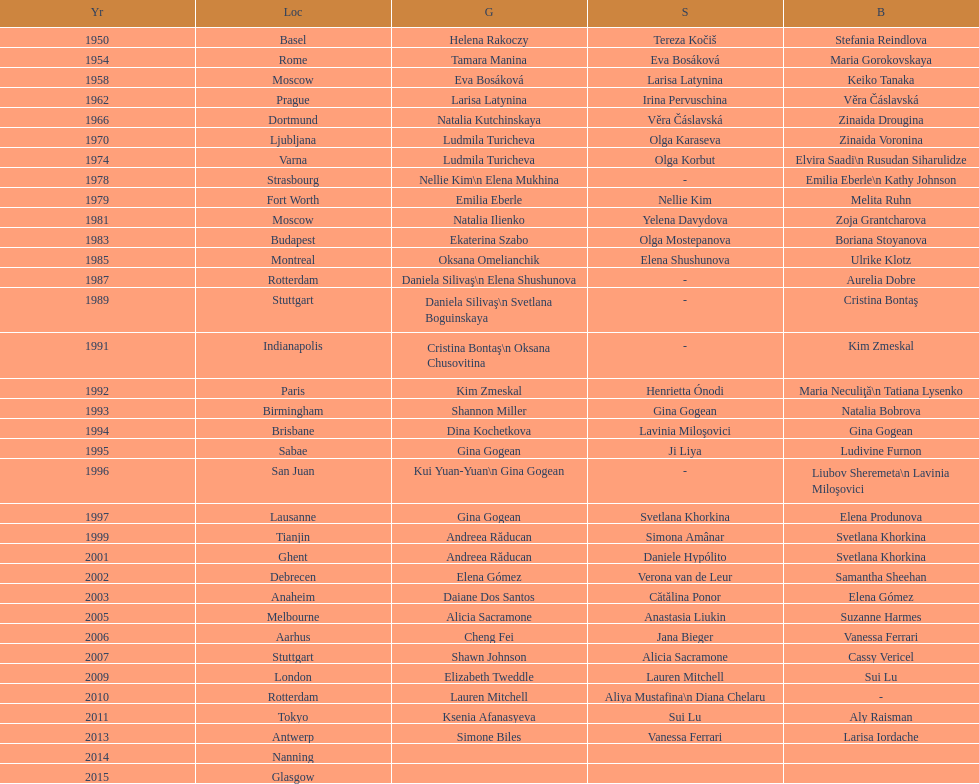How many occasions was the world artistic gymnastics championships conducted in the united states? 3. 